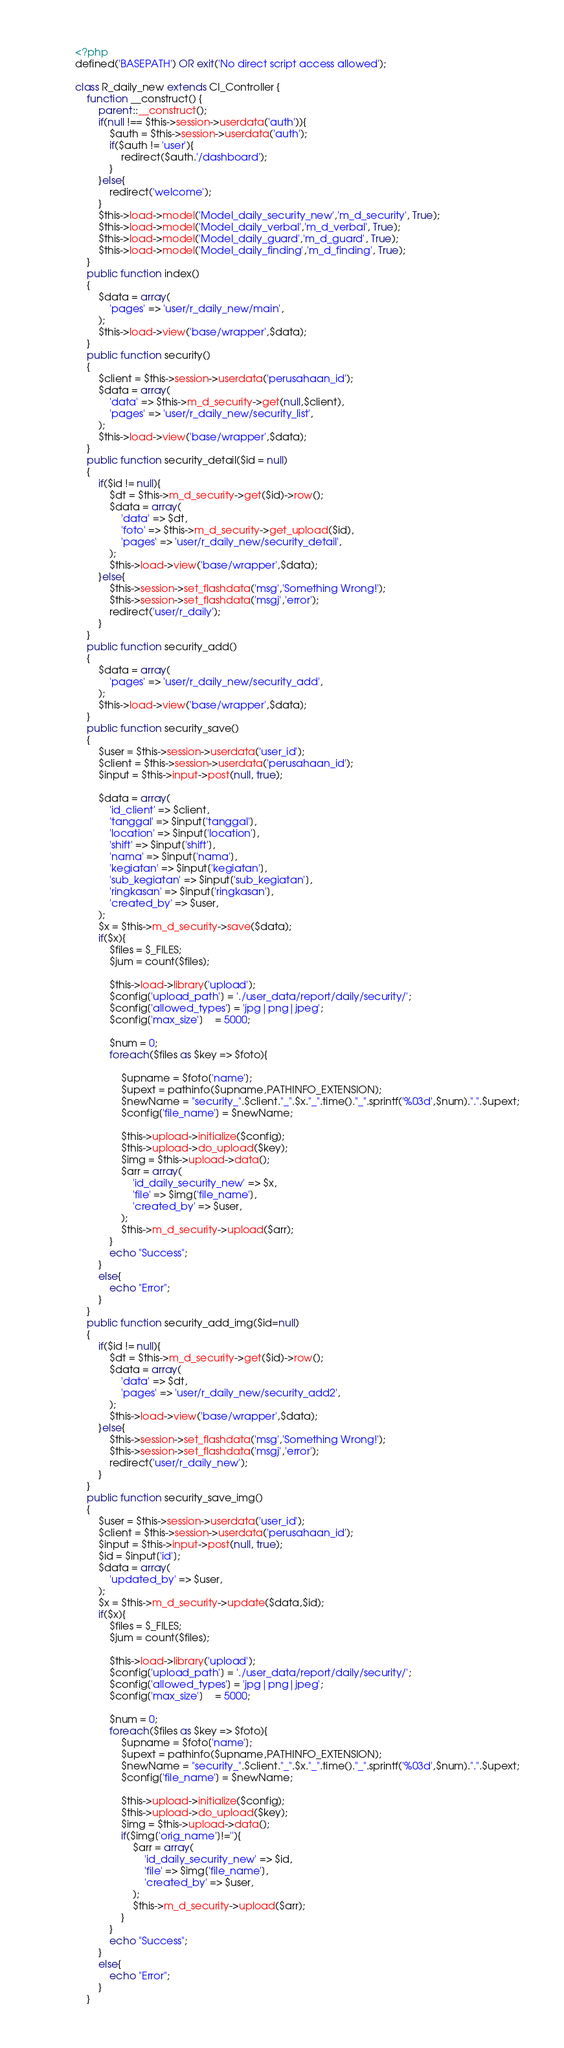Convert code to text. <code><loc_0><loc_0><loc_500><loc_500><_PHP_><?php
defined('BASEPATH') OR exit('No direct script access allowed');

class R_daily_new extends CI_Controller {
	function __construct() {
        parent::__construct();
		if(null !== $this->session->userdata('auth')){
			$auth = $this->session->userdata('auth');
			if($auth != 'user'){
				redirect($auth.'/dashboard');
			}
		}else{
			redirect('welcome');
		}
		$this->load->model('Model_daily_security_new','m_d_security', True);
		$this->load->model('Model_daily_verbal','m_d_verbal', True);
		$this->load->model('Model_daily_guard','m_d_guard', True);
		$this->load->model('Model_daily_finding','m_d_finding', True);
	}
	public function index()
	{
		$data = array(
			'pages' => 'user/r_daily_new/main',
		);
		$this->load->view('base/wrapper',$data);
    }
    public function security()
	{
		$client = $this->session->userdata('perusahaan_id');
		$data = array(
			'data' => $this->m_d_security->get(null,$client),
			'pages' => 'user/r_daily_new/security_list',
		);
		$this->load->view('base/wrapper',$data);
    }
	public function security_detail($id = null)
	{
		if($id != null){
			$dt = $this->m_d_security->get($id)->row();
			$data = array(
				'data' => $dt,
				'foto' => $this->m_d_security->get_upload($id),
				'pages' => 'user/r_daily_new/security_detail',
			);
			$this->load->view('base/wrapper',$data);
		}else{
			$this->session->set_flashdata('msg','Something Wrong!');
			$this->session->set_flashdata('msgj','error');
			redirect('user/r_daily');
		}
    }
    public function security_add()
	{
		$data = array(
			'pages' => 'user/r_daily_new/security_add',
		);
		$this->load->view('base/wrapper',$data);
    }
    public function security_save()
	{
		$user = $this->session->userdata('user_id');
		$client = $this->session->userdata('perusahaan_id');
		$input = $this->input->post(null, true);

		$data = array(
			'id_client' => $client,
			'tanggal' => $input['tanggal'],
			'location' => $input['location'],
			'shift' => $input['shift'],
			'nama' => $input['nama'],
			'kegiatan' => $input['kegiatan'],
			'sub_kegiatan' => $input['sub_kegiatan'],
			'ringkasan' => $input['ringkasan'],
			'created_by' => $user,
		);
		$x = $this->m_d_security->save($data);
		if($x){
			$files = $_FILES;
			$jum = count($files);

			$this->load->library('upload');
			$config['upload_path'] = './user_data/report/daily/security/';       
			$config['allowed_types'] = 'jpg|png|jpeg';           
			$config['max_size']    = 5000;

			$num = 0;
			foreach($files as $key => $foto){

				$upname = $foto['name'];
				$upext = pathinfo($upname,PATHINFO_EXTENSION);
				$newName = "security_".$client."_".$x."_".time()."_".sprintf('%03d',$num).".".$upext;
				$config['file_name'] = $newName;  

				$this->upload->initialize($config);
				$this->upload->do_upload($key);
				$img = $this->upload->data();
				$arr = array(
					'id_daily_security_new' => $x,
					'file' => $img['file_name'],
					'created_by' => $user,
				);
				$this->m_d_security->upload($arr);
			}
			echo "Success";
		}
		else{
			echo "Error";
		}
    }
	public function security_add_img($id=null)
	{
		if($id != null){
			$dt = $this->m_d_security->get($id)->row();
			$data = array(
				'data' => $dt,
				'pages' => 'user/r_daily_new/security_add2',
			);
			$this->load->view('base/wrapper',$data);
		}else{
			$this->session->set_flashdata('msg','Something Wrong!');
			$this->session->set_flashdata('msgj','error');
			redirect('user/r_daily_new');
		}
    }
	public function security_save_img()
	{
		$user = $this->session->userdata('user_id');
		$client = $this->session->userdata('perusahaan_id');
		$input = $this->input->post(null, true);
		$id = $input['id'];
		$data = array(
			'updated_by' => $user,
		);
		$x = $this->m_d_security->update($data,$id);
		if($x){
			$files = $_FILES;
			$jum = count($files);

			$this->load->library('upload');
			$config['upload_path'] = './user_data/report/daily/security/';       
			$config['allowed_types'] = 'jpg|png|jpeg';           
			$config['max_size']    = 5000;

			$num = 0;
			foreach($files as $key => $foto){
				$upname = $foto['name'];
				$upext = pathinfo($upname,PATHINFO_EXTENSION);
				$newName = "security_".$client."_".$x."_".time()."_".sprintf('%03d',$num).".".$upext;
				$config['file_name'] = $newName;  

				$this->upload->initialize($config);
				$this->upload->do_upload($key);
				$img = $this->upload->data();
				if($img['orig_name']!=''){
					$arr = array(
						'id_daily_security_new' => $id,
						'file' => $img['file_name'],
						'created_by' => $user,
					);
					$this->m_d_security->upload($arr);
				}
			}
			echo "Success";
		}
		else{
			echo "Error";
		}
    }</code> 